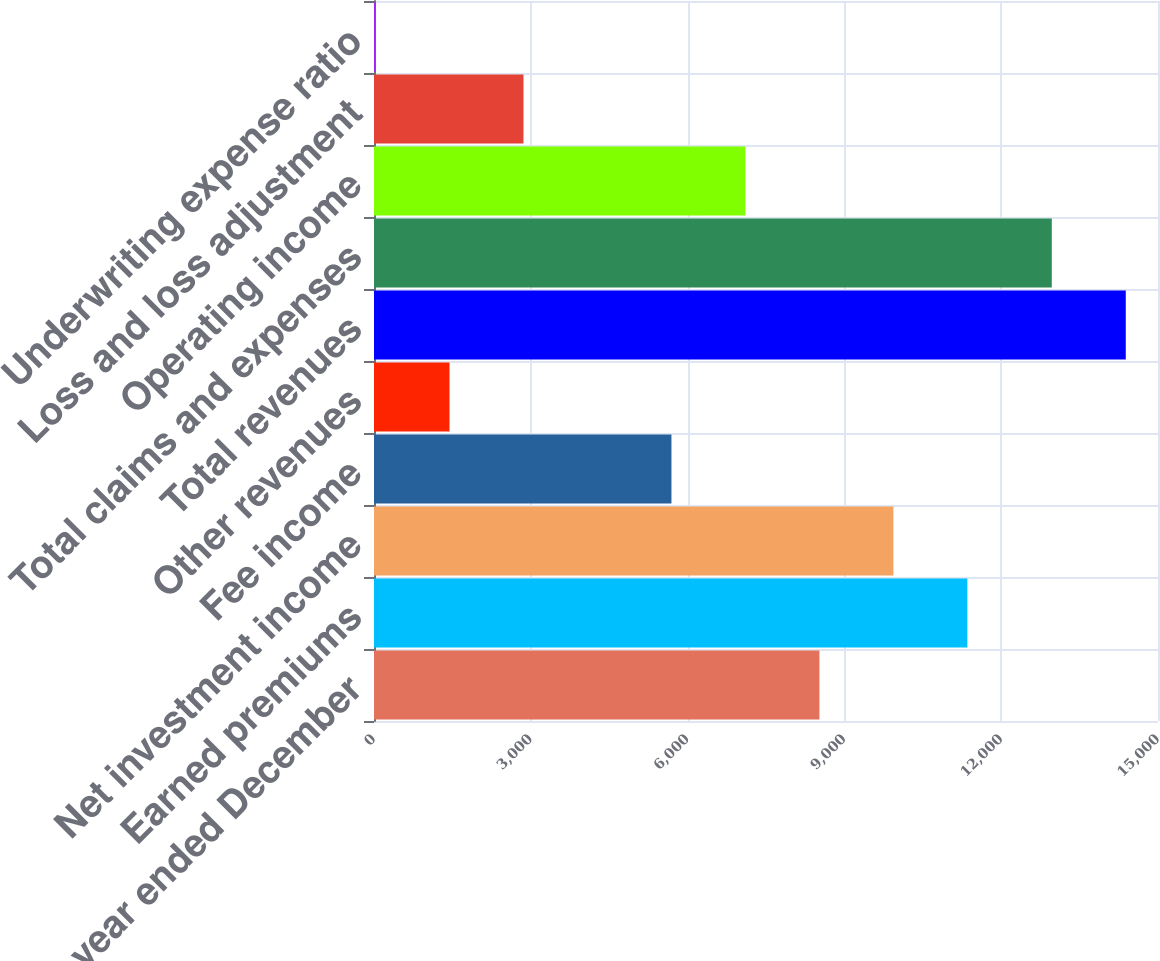<chart> <loc_0><loc_0><loc_500><loc_500><bar_chart><fcel>(for the year ended December<fcel>Earned premiums<fcel>Net investment income<fcel>Fee income<fcel>Other revenues<fcel>Total revenues<fcel>Total claims and expenses<fcel>Operating income<fcel>Loss and loss adjustment<fcel>Underwriting expense ratio<nl><fcel>8521.96<fcel>11353<fcel>9937.47<fcel>5690.94<fcel>1444.41<fcel>14383.5<fcel>12968<fcel>7106.45<fcel>2859.92<fcel>28.9<nl></chart> 